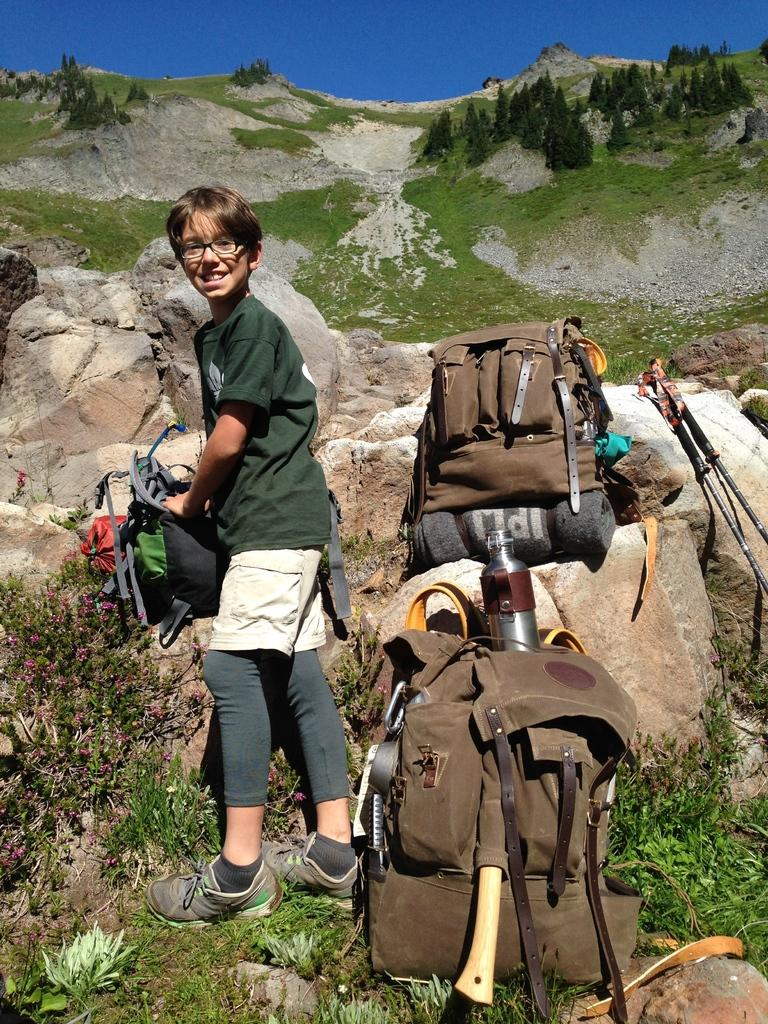What is the main subject of the image? There is a child standing in the image. What else can be seen in the image besides the child? Bags are present in the image. What type of environment is depicted in the image? Grass is visible in the image, suggesting an outdoor setting. What type of protest is the turkey leading in the image? There is no turkey or protest present in the image; it features a child standing and bags. Who is the expert in the image? There is no expert present in the image; it features a child standing and bags. 